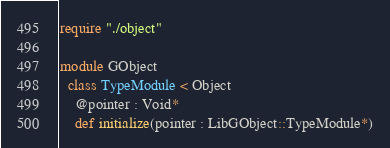<code> <loc_0><loc_0><loc_500><loc_500><_Crystal_>require "./object"

module GObject
  class TypeModule < Object
    @pointer : Void*
    def initialize(pointer : LibGObject::TypeModule*)</code> 